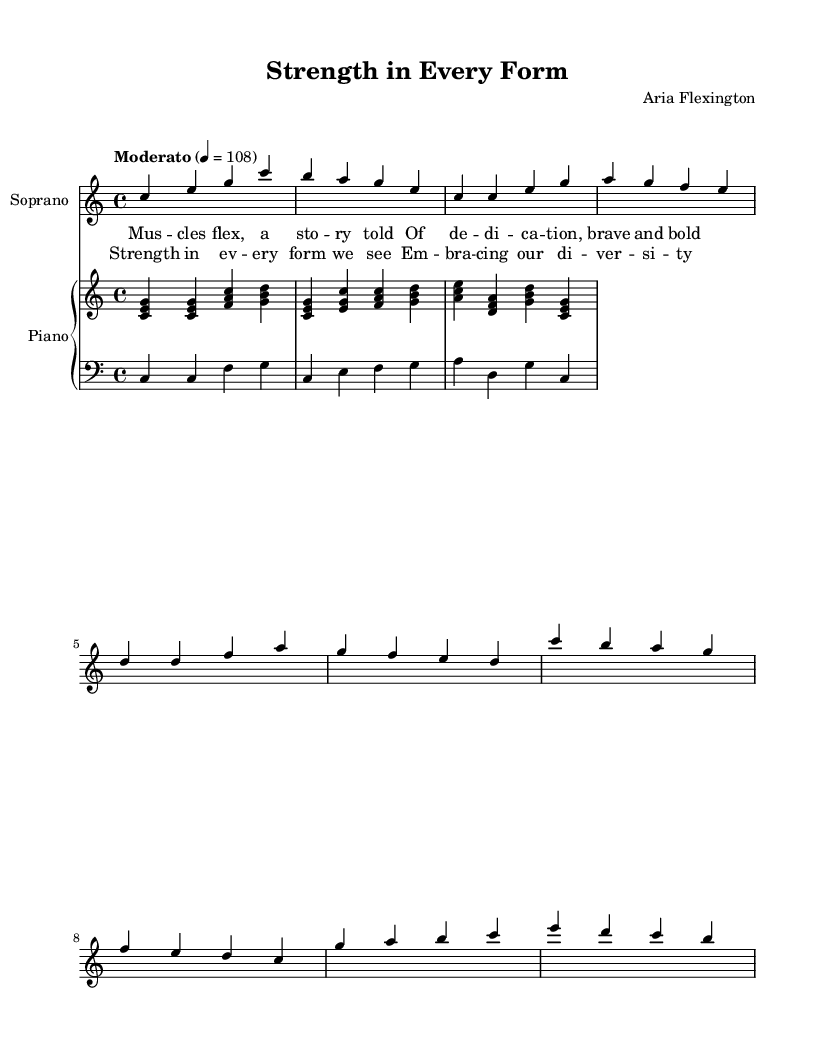What is the key signature of this music? The key signature is C major, which has no sharps or flats indicated in the music.
Answer: C major What is the time signature of the piece? The time signature is shown at the beginning of the sheet music as 4/4, which indicates four beats in each measure.
Answer: 4/4 What is the tempo marking for this piece? The tempo is indicated as "Moderato" with a metronome marking of 108 beats per minute, showing that the piece should be played at a moderate speed.
Answer: Moderato How many measures are there in the introduction? Counting the measures in the introduction section, there are 2 measures before the first verse starts.
Answer: 2 measures What theme is reflected in the lyrics of this opera? The lyrics express themes of strength and body positivity, emphasizing diversity and empowerment in every form.
Answer: Body positivity Who is the composer of this opera? The composer's name is provided in the header section of the sheet music, which is Aria Flexington.
Answer: Aria Flexington What vocal range is indicated for this piece? The vocal range is indicated at the beginning of the score which shows it is specifically for "Soprano".
Answer: Soprano 